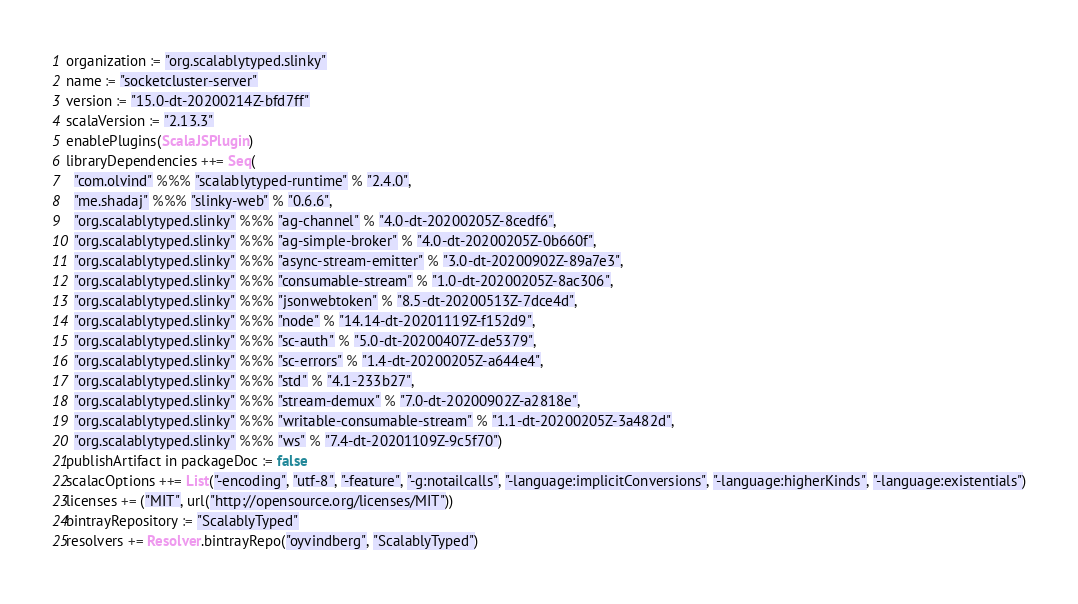<code> <loc_0><loc_0><loc_500><loc_500><_Scala_>organization := "org.scalablytyped.slinky"
name := "socketcluster-server"
version := "15.0-dt-20200214Z-bfd7ff"
scalaVersion := "2.13.3"
enablePlugins(ScalaJSPlugin)
libraryDependencies ++= Seq(
  "com.olvind" %%% "scalablytyped-runtime" % "2.4.0",
  "me.shadaj" %%% "slinky-web" % "0.6.6",
  "org.scalablytyped.slinky" %%% "ag-channel" % "4.0-dt-20200205Z-8cedf6",
  "org.scalablytyped.slinky" %%% "ag-simple-broker" % "4.0-dt-20200205Z-0b660f",
  "org.scalablytyped.slinky" %%% "async-stream-emitter" % "3.0-dt-20200902Z-89a7e3",
  "org.scalablytyped.slinky" %%% "consumable-stream" % "1.0-dt-20200205Z-8ac306",
  "org.scalablytyped.slinky" %%% "jsonwebtoken" % "8.5-dt-20200513Z-7dce4d",
  "org.scalablytyped.slinky" %%% "node" % "14.14-dt-20201119Z-f152d9",
  "org.scalablytyped.slinky" %%% "sc-auth" % "5.0-dt-20200407Z-de5379",
  "org.scalablytyped.slinky" %%% "sc-errors" % "1.4-dt-20200205Z-a644e4",
  "org.scalablytyped.slinky" %%% "std" % "4.1-233b27",
  "org.scalablytyped.slinky" %%% "stream-demux" % "7.0-dt-20200902Z-a2818e",
  "org.scalablytyped.slinky" %%% "writable-consumable-stream" % "1.1-dt-20200205Z-3a482d",
  "org.scalablytyped.slinky" %%% "ws" % "7.4-dt-20201109Z-9c5f70")
publishArtifact in packageDoc := false
scalacOptions ++= List("-encoding", "utf-8", "-feature", "-g:notailcalls", "-language:implicitConversions", "-language:higherKinds", "-language:existentials")
licenses += ("MIT", url("http://opensource.org/licenses/MIT"))
bintrayRepository := "ScalablyTyped"
resolvers += Resolver.bintrayRepo("oyvindberg", "ScalablyTyped")
</code> 